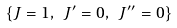Convert formula to latex. <formula><loc_0><loc_0><loc_500><loc_500>\left \{ J = 1 , \ J ^ { \prime } = 0 , \ J ^ { \prime \prime } = 0 \right \}</formula> 